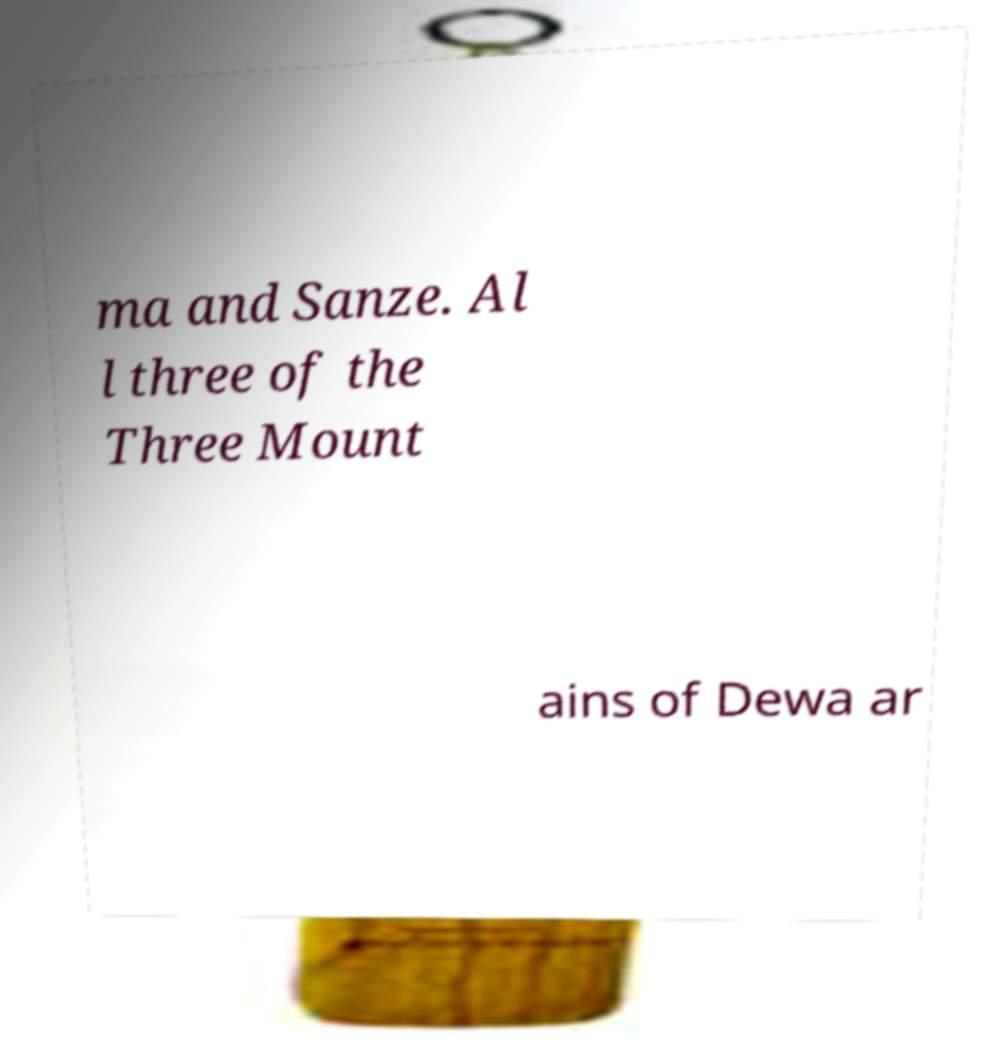Could you extract and type out the text from this image? ma and Sanze. Al l three of the Three Mount ains of Dewa ar 